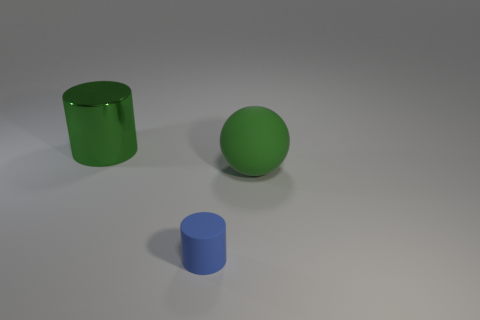What material is the object left of the cylinder to the right of the large metal cylinder?
Offer a terse response. Metal. Does the large thing to the right of the large green shiny object have the same color as the large metal object?
Your response must be concise. Yes. Is there any other thing that has the same material as the green cylinder?
Ensure brevity in your answer.  No. How many small rubber things have the same shape as the green shiny object?
Provide a short and direct response. 1. What size is the green ball that is the same material as the small blue cylinder?
Offer a terse response. Large. Are there any large green objects in front of the large shiny cylinder left of the blue thing in front of the green shiny thing?
Make the answer very short. Yes. Do the green object on the left side of the ball and the green matte ball have the same size?
Offer a very short reply. Yes. What number of green balls are the same size as the green cylinder?
Provide a short and direct response. 1. There is a thing that is the same color as the ball; what size is it?
Offer a terse response. Large. Is the color of the big rubber sphere the same as the metal cylinder?
Your answer should be compact. Yes. 